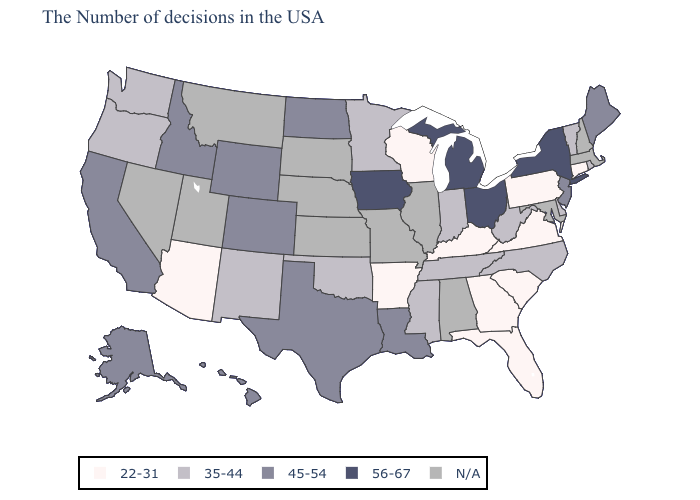Does Louisiana have the highest value in the South?
Short answer required. Yes. Name the states that have a value in the range N/A?
Give a very brief answer. Massachusetts, New Hampshire, Maryland, Alabama, Illinois, Missouri, Kansas, Nebraska, South Dakota, Utah, Montana, Nevada. Name the states that have a value in the range 35-44?
Give a very brief answer. Rhode Island, Vermont, Delaware, North Carolina, West Virginia, Indiana, Tennessee, Mississippi, Minnesota, Oklahoma, New Mexico, Washington, Oregon. Among the states that border New York , which have the lowest value?
Answer briefly. Connecticut, Pennsylvania. Among the states that border Vermont , which have the highest value?
Write a very short answer. New York. Name the states that have a value in the range 56-67?
Quick response, please. New York, Ohio, Michigan, Iowa. What is the value of Hawaii?
Concise answer only. 45-54. Does California have the highest value in the West?
Write a very short answer. Yes. Name the states that have a value in the range 56-67?
Write a very short answer. New York, Ohio, Michigan, Iowa. Among the states that border Mississippi , which have the highest value?
Answer briefly. Louisiana. Name the states that have a value in the range N/A?
Keep it brief. Massachusetts, New Hampshire, Maryland, Alabama, Illinois, Missouri, Kansas, Nebraska, South Dakota, Utah, Montana, Nevada. 